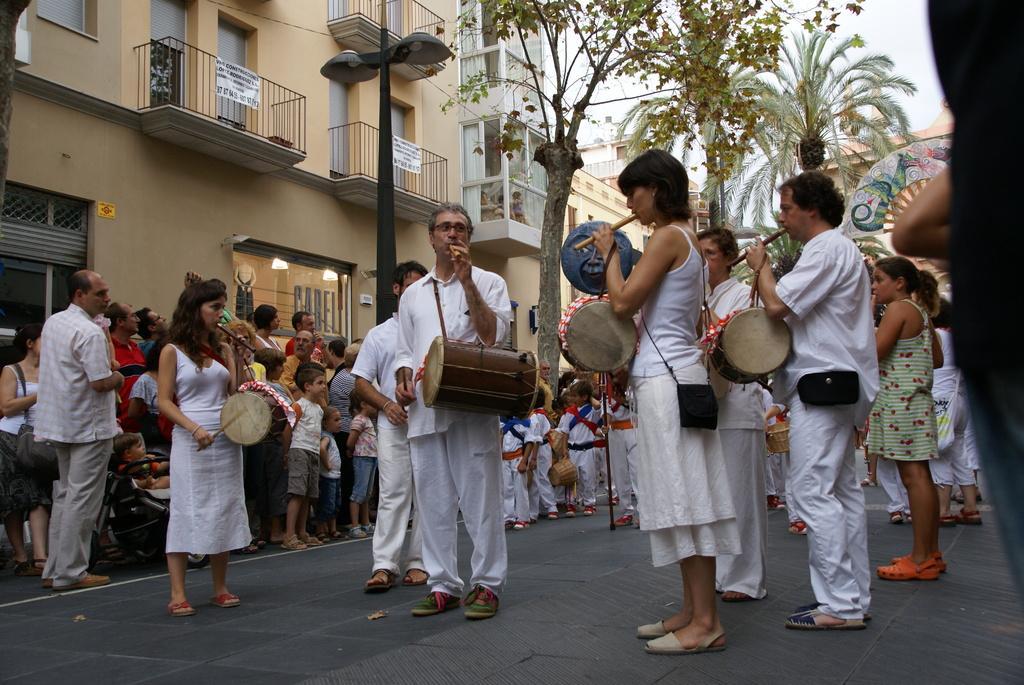How would you summarize this image in a sentence or two? In this image few persons are standing on road are wearing white dress are having drums and flute. At left side there are few persons standing. In the middle of image there are few kids standing. At the left side there is a baby in baby trolly. Backside there is a building. There is a pole having street lights on the pavement. There are trees and sky at the top of the image. 